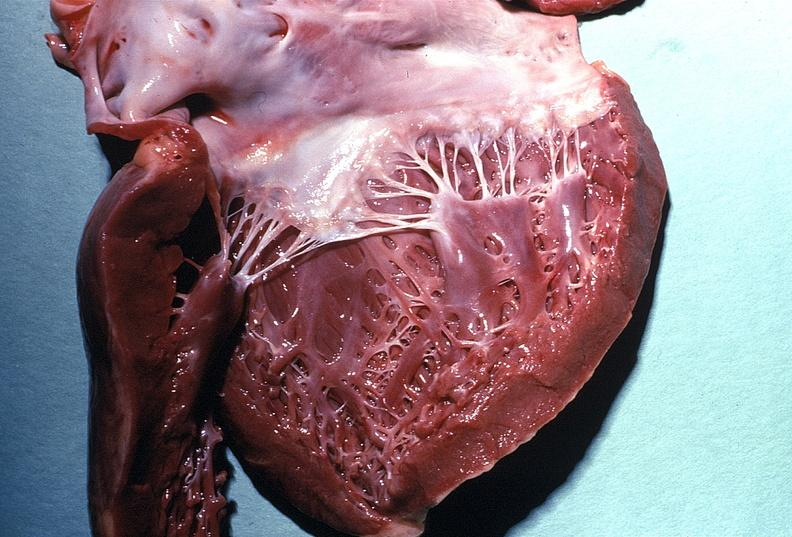does acute lymphocytic leukemia show normal mitral valve?
Answer the question using a single word or phrase. No 